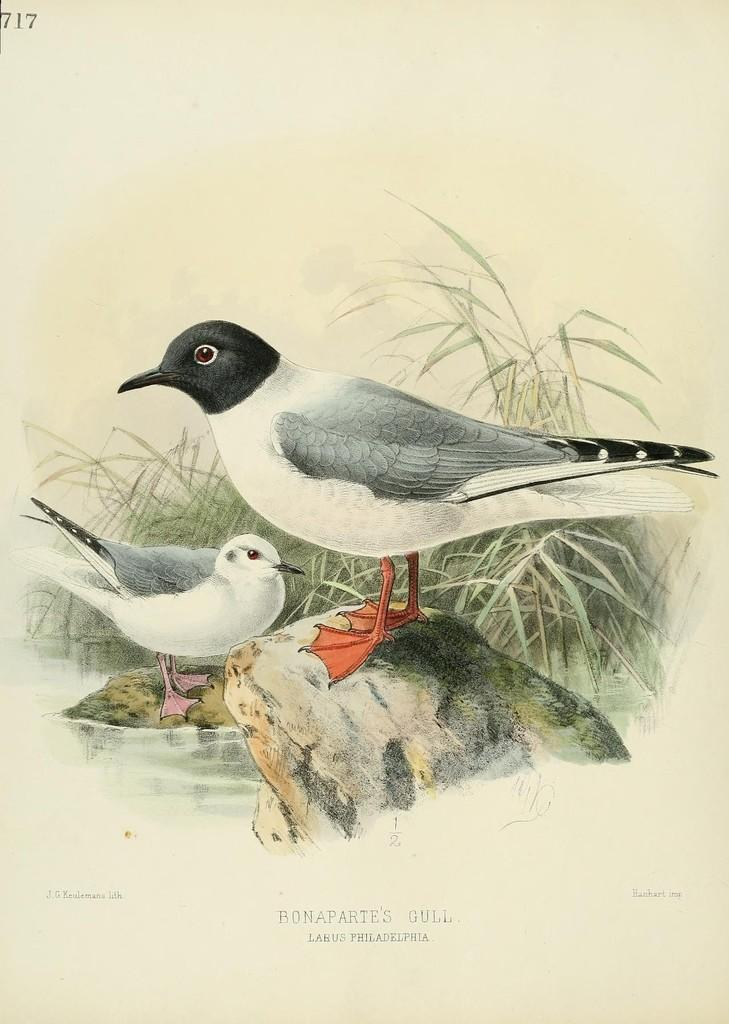What type of animals can be seen in the image? There are birds in the image. Where are the birds located? The birds are on rocks in the image. What type of vegetation is present in the image? There is grass in the image. What natural element is also visible in the image? There is water in the image. What type of trade is being conducted by the birds in the image? There is no indication of trade in the image; it simply shows birds on rocks. 